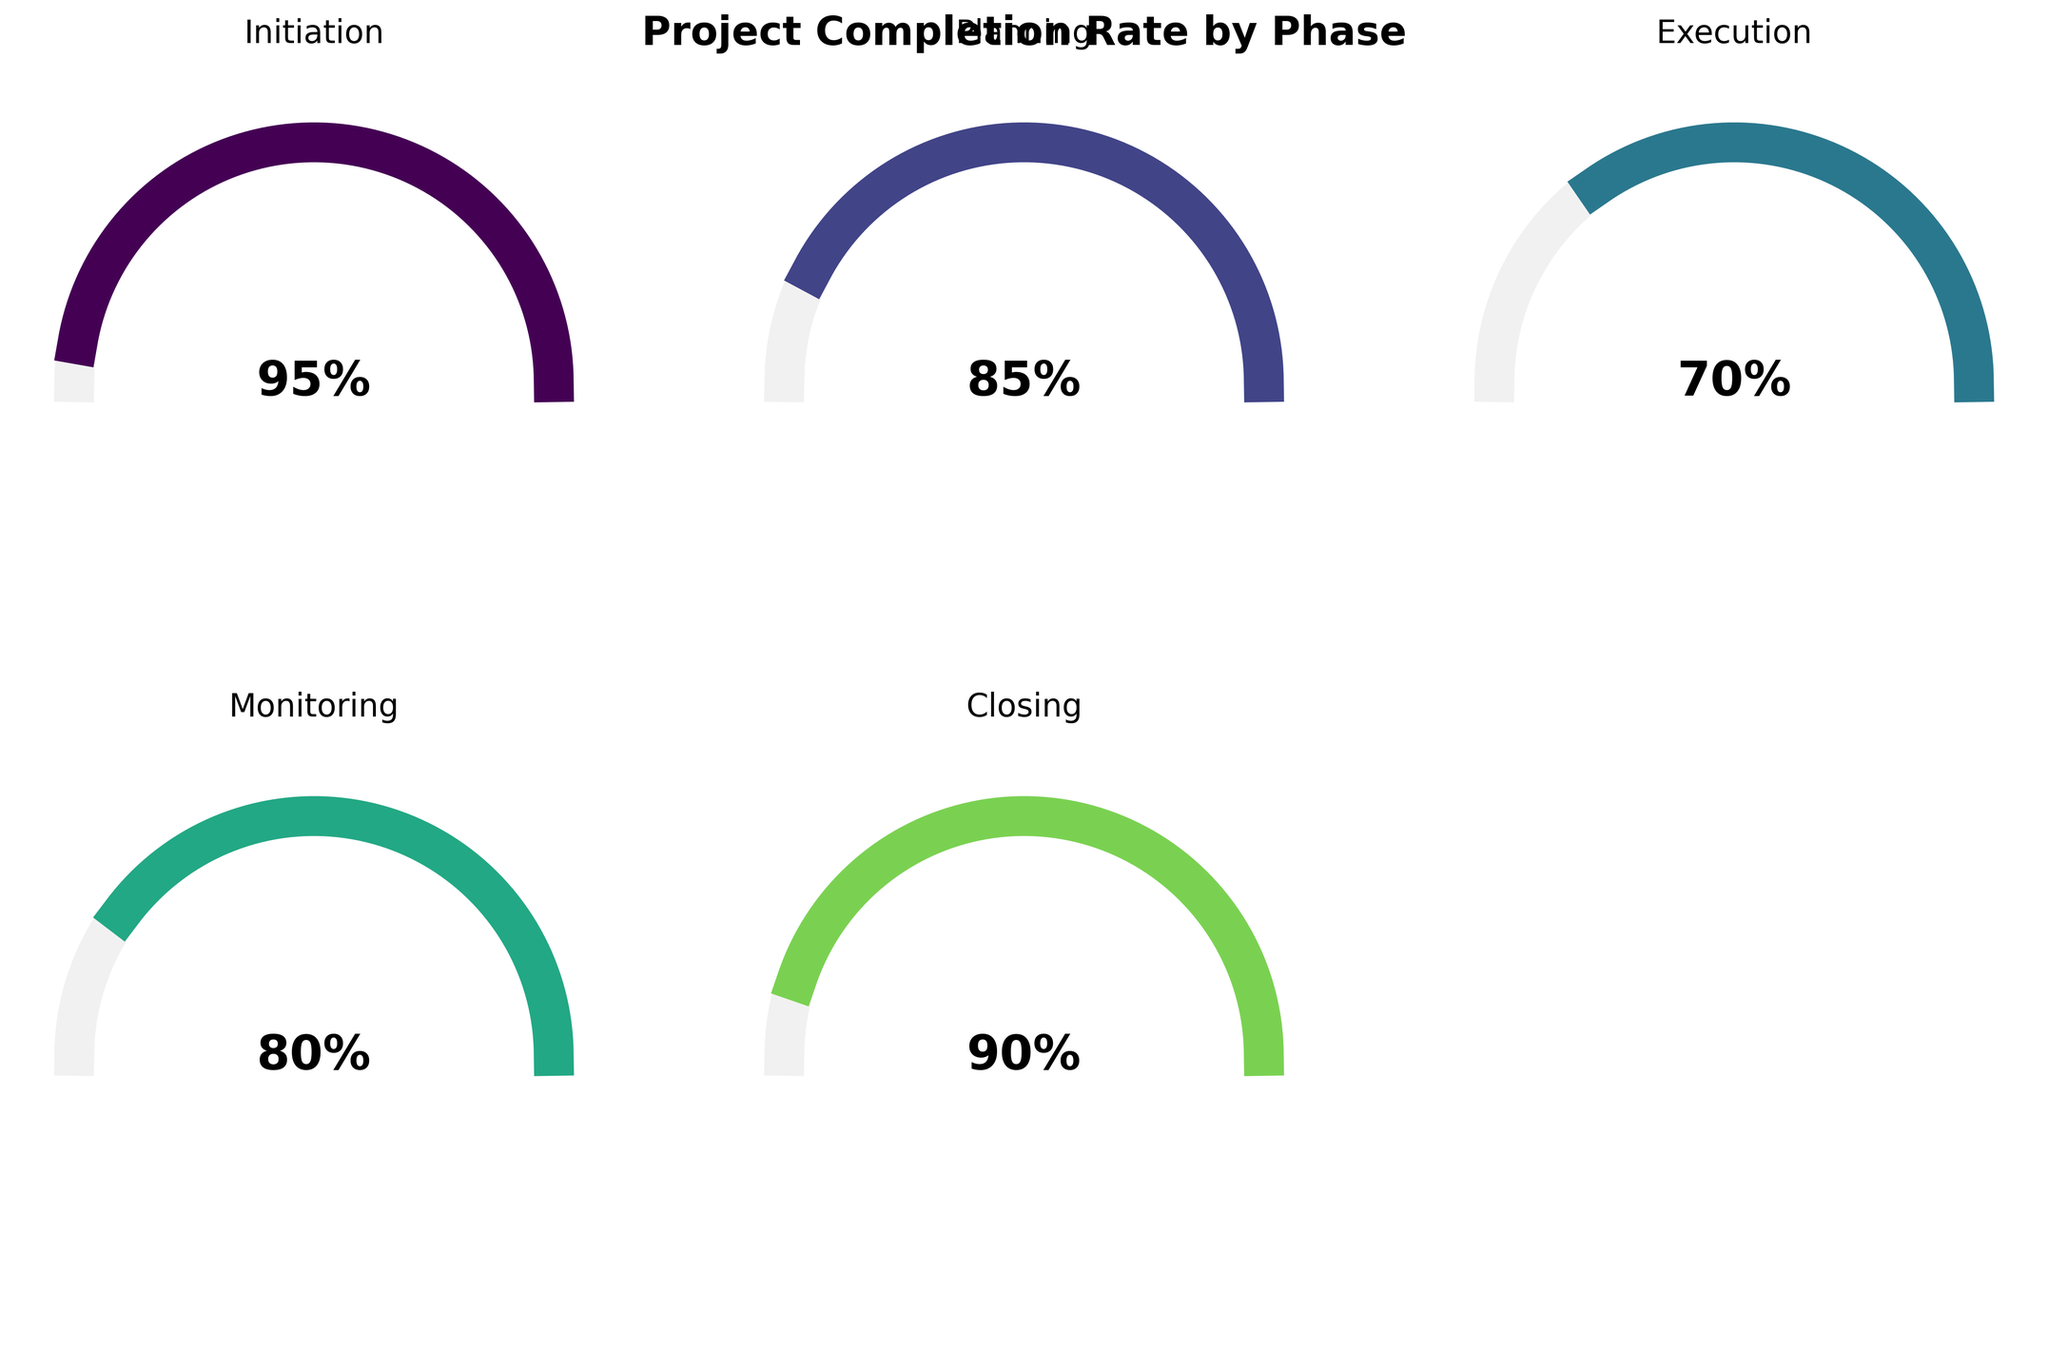What's the project completion rate for the Initiation phase? The gauge chart for the Initiation phase shows a completion rate highlighted at 95%.
Answer: 95% What phase has the lowest completion rate? By examining all the gauge charts, the Execution phase has the lowest completion rate at 70%.
Answer: Execution Which phase has the second highest completion rate after the Initiation phase? After the Initiation phase with a completion rate of 95%, the highest rate is for the Closing phase at 90%.
Answer: Closing What is the average completion rate for the Planning, Execution, and Monitoring phases? Add the completion rates for Planning (85), Execution (70), and Monitoring (80). The sum is 235. Divide by 3 to get the average: 235/3 = 78.33.
Answer: 78.33% How many phases have a completion rate above 80%? The phases with completion rates above 80% are Initiation (95%), Planning (85%), Closing (90%). There are 3 such phases.
Answer: 3 How much higher is the completion rate for Monitoring compared to Execution? The completion rate for Monitoring is 80% and for Execution is 70%. The difference is 80 - 70 = 10.
Answer: 10% Compare the completion rate of the Overall project to the average rate of all phases. Is it higher or lower? The average rate of all phases is (95 + 85 + 70 + 80 + 90)/5 = 84%. The Overall project completion rate is also 84%. So, they are equal.
Answer: Equal Which phase is closest in completion rate to the Overall project? The Overall project's completion rate is 84%. The closest phase is Planning with a rate of 85%.
Answer: Planning 